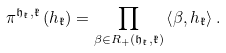Convert formula to latex. <formula><loc_0><loc_0><loc_500><loc_500>\pi ^ { \mathfrak h _ { \mathfrak k } , \mathfrak k } \left ( h _ { \mathfrak k } \right ) = \prod _ { \beta \in R _ { + } \left ( \mathfrak h _ { \mathfrak k } , \mathfrak k \right ) } \left \langle \beta , h _ { \mathfrak k } \right \rangle .</formula> 